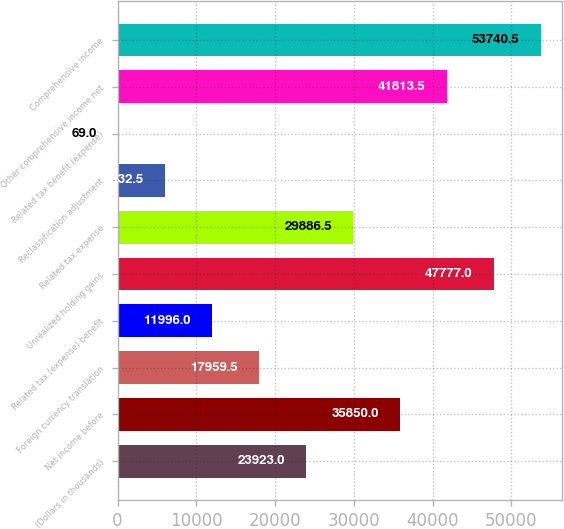<chart> <loc_0><loc_0><loc_500><loc_500><bar_chart><fcel>(Dollars in thousands)<fcel>Net income before<fcel>Foreign currency translation<fcel>Related tax (expense) benefit<fcel>Unrealized holding gains<fcel>Related tax expense<fcel>Reclassification adjustment<fcel>Related tax benefit (expense)<fcel>Other comprehensive income net<fcel>Comprehensive income<nl><fcel>23923<fcel>35850<fcel>17959.5<fcel>11996<fcel>47777<fcel>29886.5<fcel>6032.5<fcel>69<fcel>41813.5<fcel>53740.5<nl></chart> 